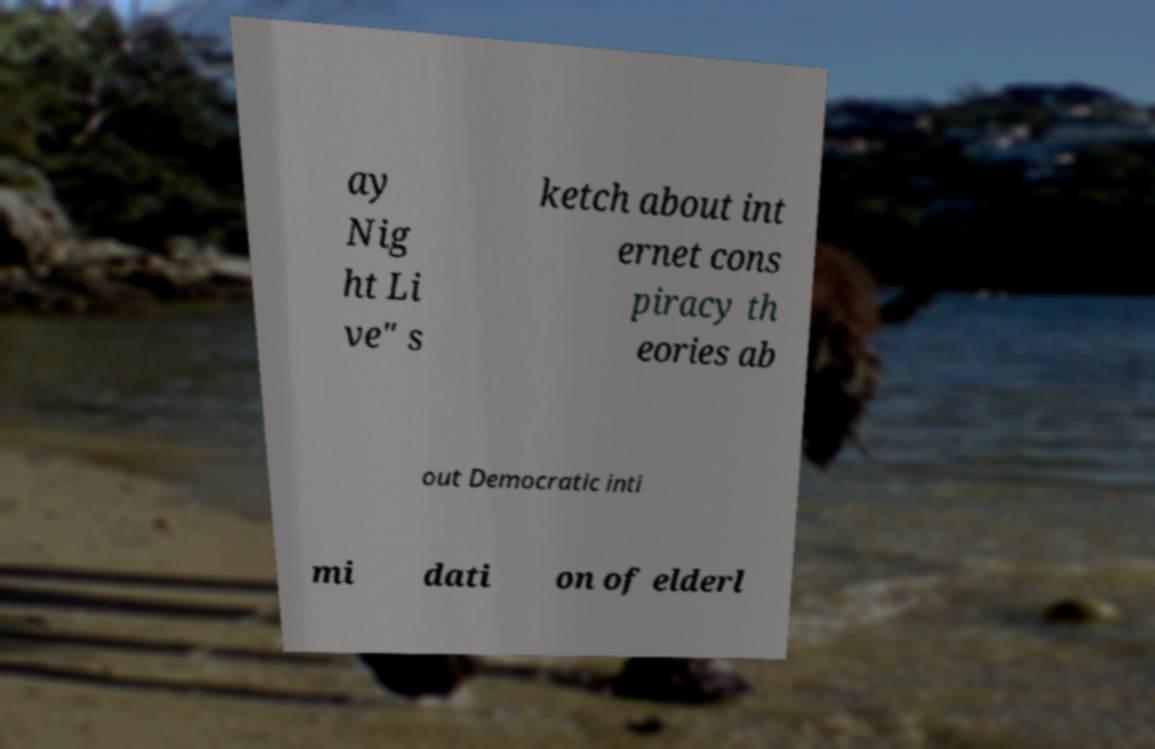Please read and relay the text visible in this image. What does it say? ay Nig ht Li ve" s ketch about int ernet cons piracy th eories ab out Democratic inti mi dati on of elderl 